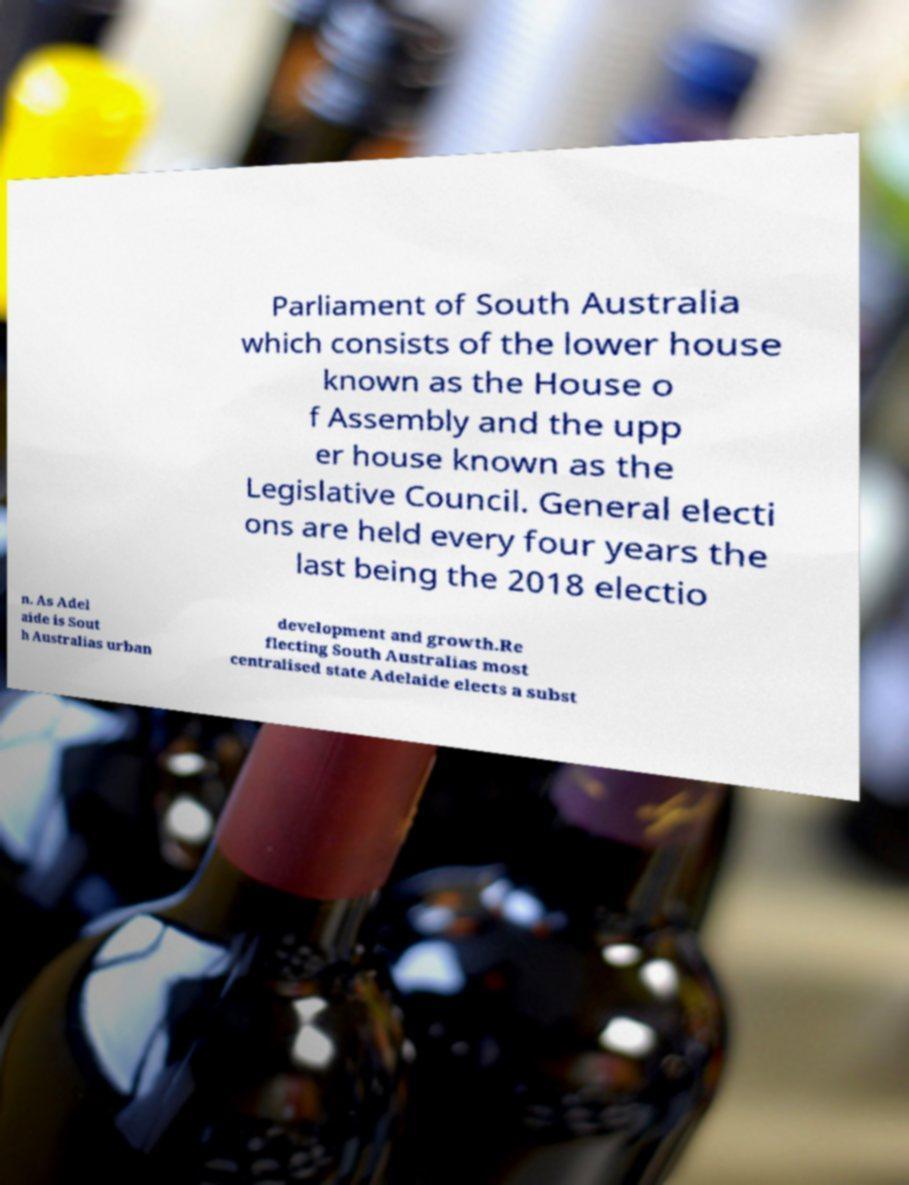Please identify and transcribe the text found in this image. Parliament of South Australia which consists of the lower house known as the House o f Assembly and the upp er house known as the Legislative Council. General electi ons are held every four years the last being the 2018 electio n. As Adel aide is Sout h Australias urban development and growth.Re flecting South Australias most centralised state Adelaide elects a subst 